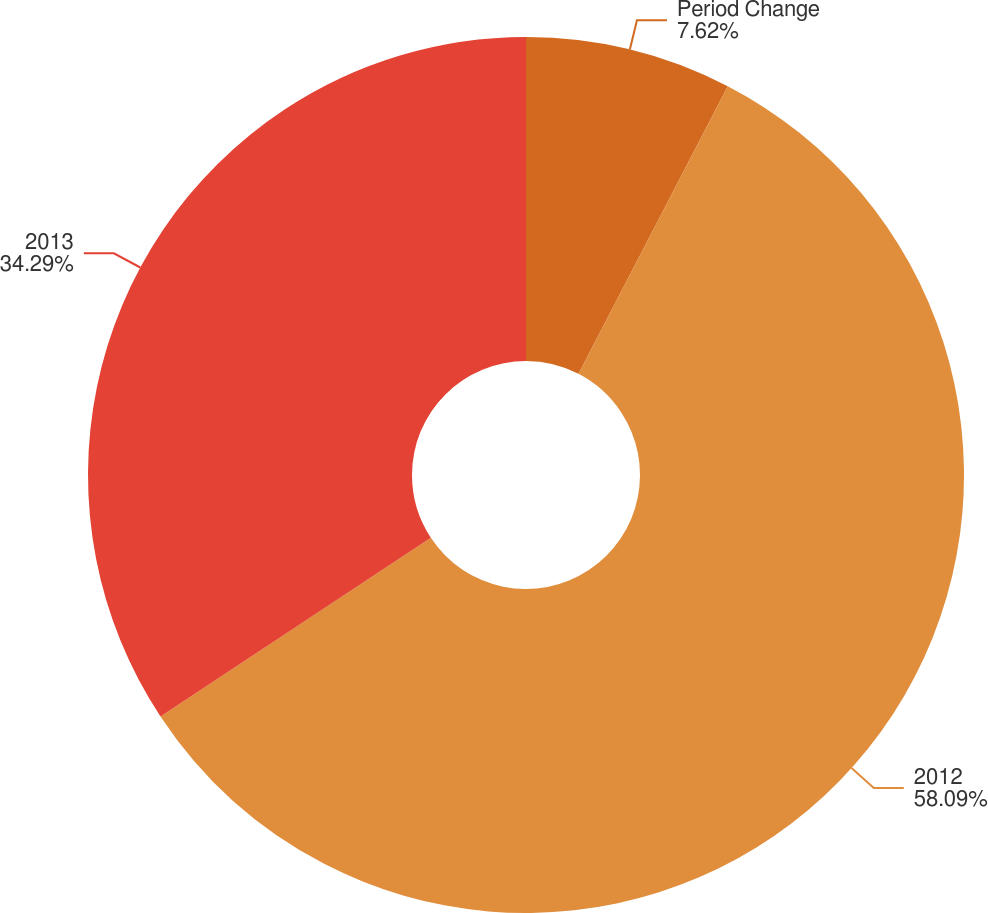Convert chart to OTSL. <chart><loc_0><loc_0><loc_500><loc_500><pie_chart><fcel>Period Change<fcel>2012<fcel>2013<nl><fcel>7.62%<fcel>58.09%<fcel>34.29%<nl></chart> 